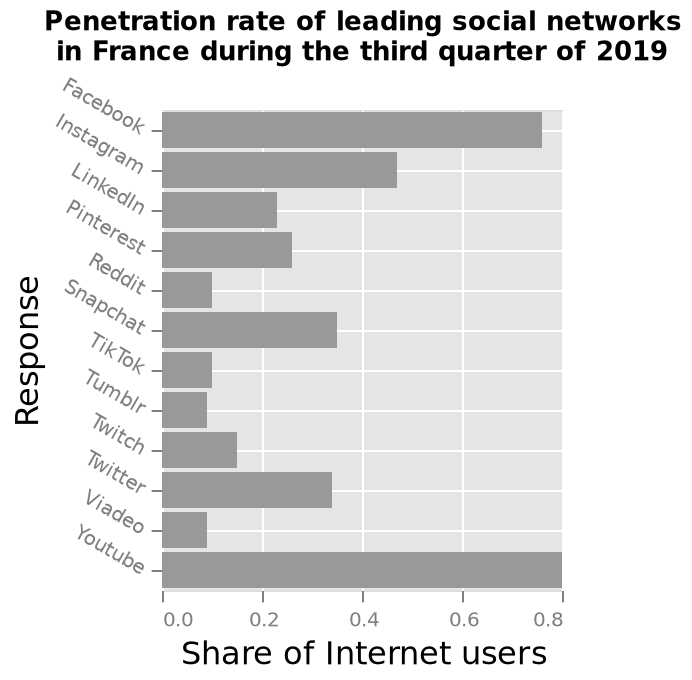<image>
What time period does the data in the bar chart represent? The data in the bar chart represents the third quarter of 2019. Were YouTube and Facebook the only platforms mentioned with a penetration rate above 0.6? Yes, according to the description, YouTube and Facebook had a higher penetration rate in France than all others, with the share of internet users for each above 0.6. Which platform had the highest penetration rate among YouTube and Facebook? YouTube had the highest penetration rate. 